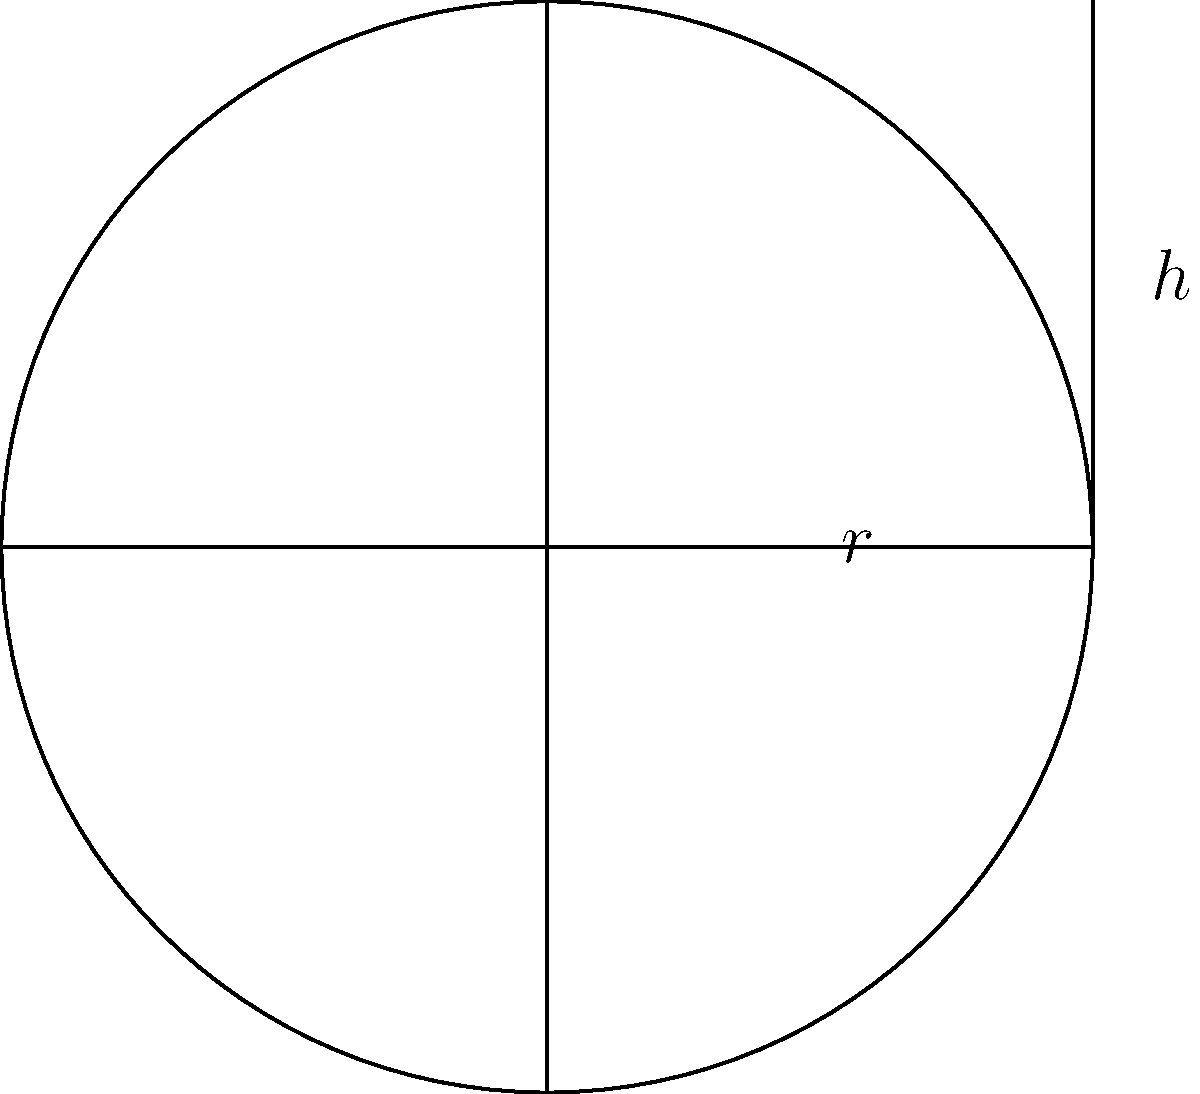As a firefighter, you need to calculate the volume of a cylindrical water tank used on your fire truck. The tank has a radius of 2 feet and a height of 6 feet. What is the volume of the tank in cubic feet? Round your answer to the nearest whole number. To calculate the volume of a cylindrical tank, we use the formula:

$$V = \pi r^2 h$$

Where:
$V$ = volume
$r$ = radius
$h$ = height

Given:
$r = 2$ feet
$h = 6$ feet

Step 1: Substitute the values into the formula:
$$V = \pi (2)^2 (6)$$

Step 2: Calculate the square of the radius:
$$V = \pi (4) (6)$$

Step 3: Multiply the values inside the parentheses:
$$V = \pi (24)$$

Step 4: Multiply by π (use 3.14159 for π):
$$V = 3.14159 \times 24 = 75.39816$$

Step 5: Round to the nearest whole number:
$$V \approx 75 \text{ cubic feet}$$
Answer: 75 cubic feet 